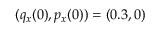<formula> <loc_0><loc_0><loc_500><loc_500>( q _ { x } ( 0 ) , p _ { x } ( 0 ) ) = ( 0 . 3 , 0 )</formula> 